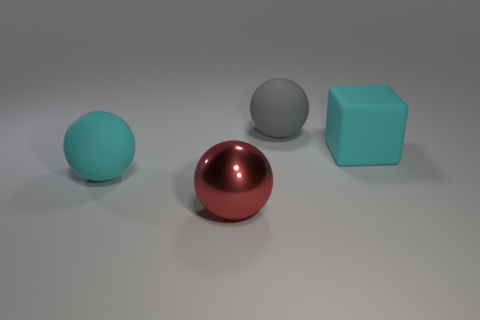How many cyan rubber objects are behind the cyan matte object in front of the cube? There are no cyan rubber objects behind the cyan matte object in front of the cube. There is only one cyan matte cube in the image, and no objects are directly behind it. 